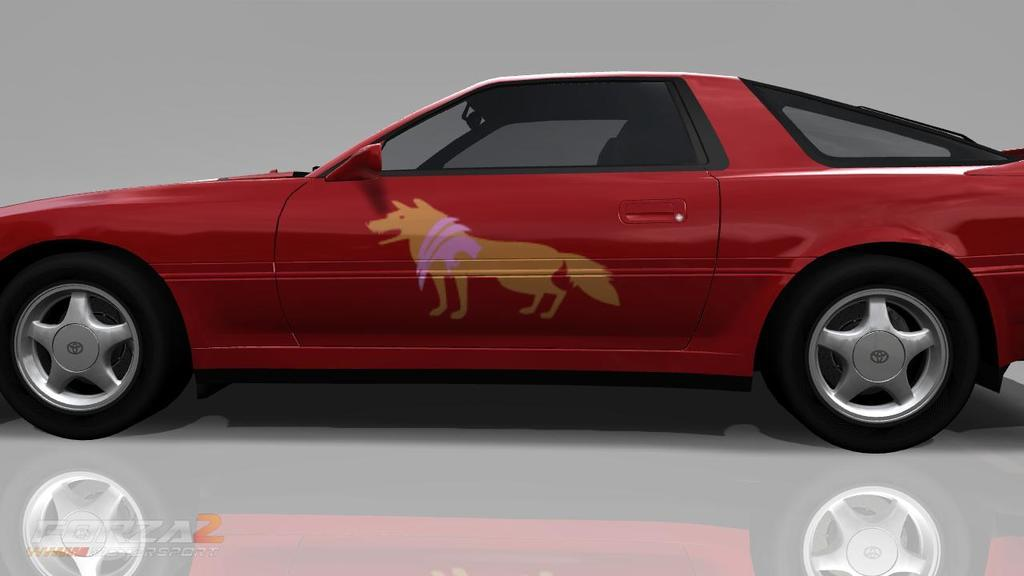What is the main subject of the image? The main subject of the image is a car. Can you describe the color of the car? The car is red and black in color. What is the surface beneath the car? The car is on a white colored surface. What color is the background of the image? The background of the image is grey in color. Is there a table with lace decorations in the image? No, there is no table or lace decorations present in the image. 